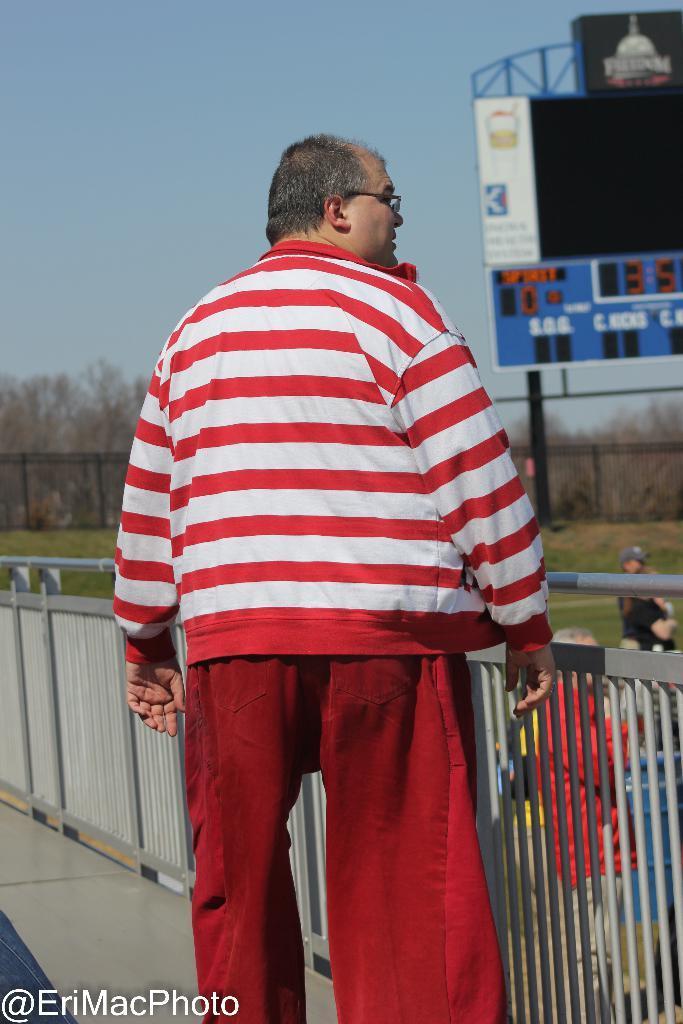How would you summarize this image in a sentence or two? In this image in the front there is a man standing. In the center there is a fence. In the background there are persons, there's grass on the ground and there is a board with some text and numbers written on it and there are trees. 